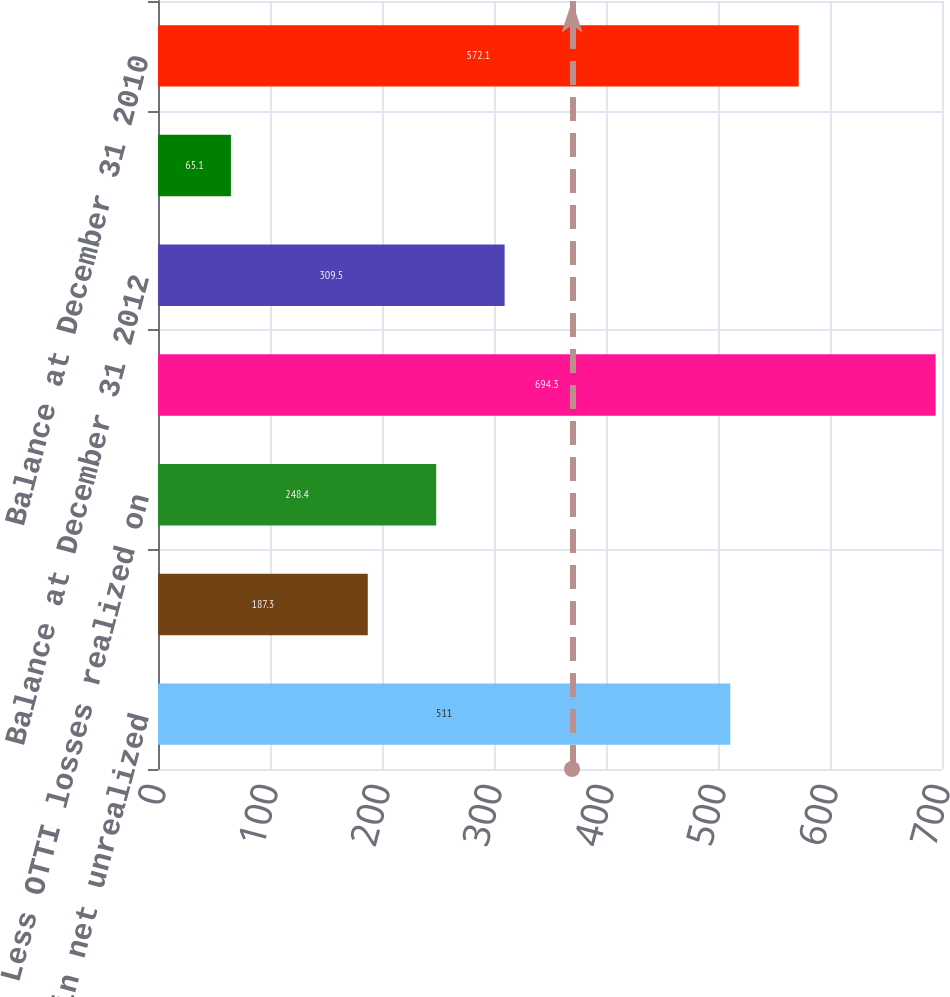Convert chart. <chart><loc_0><loc_0><loc_500><loc_500><bar_chart><fcel>Increase in net unrealized<fcel>Less Net gains (losses)<fcel>Less OTTI losses realized on<fcel>Net unrealized gains (losses)<fcel>Balance at December 31 2012<fcel>Balance at December 31 2013<fcel>Balance at December 31 2010<nl><fcel>511<fcel>187.3<fcel>248.4<fcel>694.3<fcel>309.5<fcel>65.1<fcel>572.1<nl></chart> 